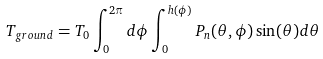Convert formula to latex. <formula><loc_0><loc_0><loc_500><loc_500>T _ { g r o u n d } = T _ { 0 } \int _ { 0 } ^ { 2 \pi } d \phi \int _ { 0 } ^ { h ( \phi ) } P _ { n } ( \theta , \phi ) \sin ( \theta ) d \theta</formula> 